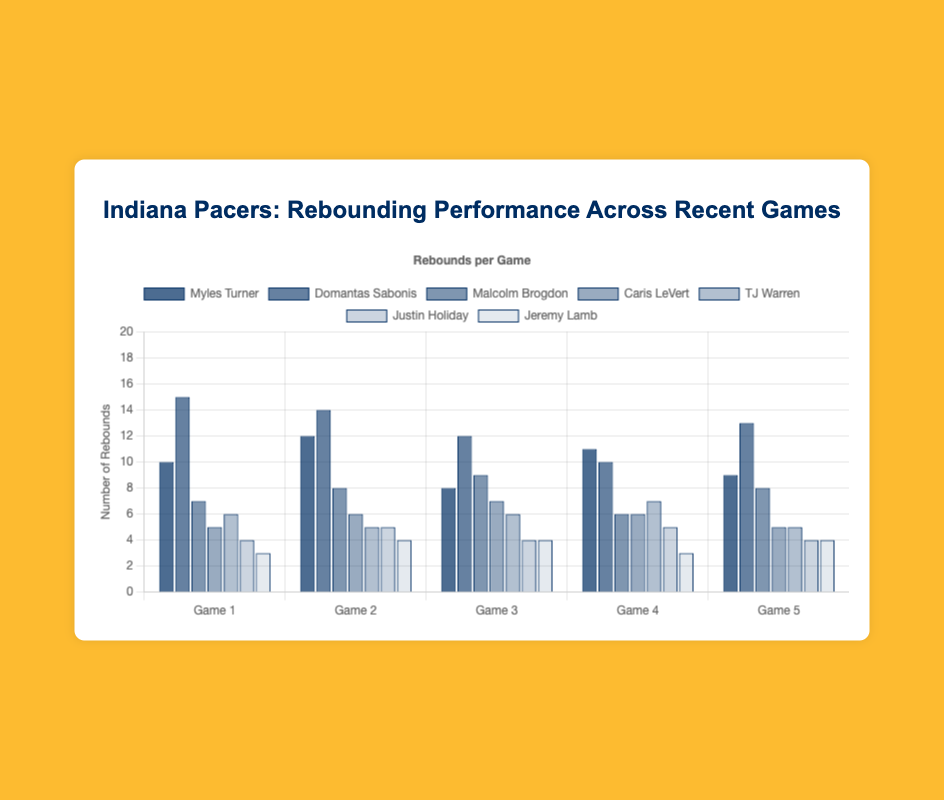Which player had the highest rebound count in Game 1? Check all the rebound counts for Game 1 - Myles Turner: 10, Domantas Sabonis: 15, Malcolm Brogdon: 7, Caris LeVert: 5, TJ Warren: 6, Justin Holiday: 4, Jeremy Lamb: 3. Domantas Sabonis has the highest rebound count with 15.
Answer: Domantas Sabonis What is the difference in total rebounds between the player with the most and the player with the least in Game 3? Calculate the total rebounds for each player in Game 3. The player with the most rebounds is Domantas Sabonis (12) and the player with the least is Justin Holiday (4). The difference is 12 - 4.
Answer: 8 Who showed the most consistent rebounding performance across all games? Consistency can be observed by minimal variation in rebounding numbers. Justin Holiday has a stable performance with 4, 5, 4, 5, 4. Check other players' variances to confirm.
Answer: Justin Holiday Which game did Myles Turner achieve his highest rebound count? Review the rebound counts for Myles Turner across all games: Game 1: 10, Game 2: 12, Game 3: 8, Game 4: 11, Game 5: 9. Highest value is 12 in Game 2.
Answer: Game 2 On average, how many rebounds per game did TJ Warren have? Calculate the average for TJ Warren by summing all his rebound counts (6+5+6+7+5) and divide by the number of games (5). The sum is 29, so the average is 29/5.
Answer: 5.8 In Game 5, which player had the second-highest rebound count? Review the rebound counts for Game 5 - Myles Turner: 9, Domantas Sabonis: 13, Malcolm Brogdon: 8, Caris LeVert: 5, TJ Warren: 5, Justin Holiday: 4, Jeremy Lamb: 4. Domantas Sabonis is highest with 13, and the second highest is Myles Turner with 9.
Answer: Myles Turner What was the total number of rebounds by Caris LeVert across all games? Sum the rebound counts for Caris LeVert for all the games: 5+6+7+6+5 = 29.
Answer: 29 Which game's rebounding performance had the least variation among all players? Check the span between the highest and lowest rebound count for each game. For example: Game 1 spans from 15(Sabonis) to 3(Lamb), Game 2 from 14(Sabonis) to 4(Lamb), and so forth. Calculate the difference for all games and find the least.
Answer: Game 4 Who scored fewer rebounds than TJ Warren in Game 3 but more in Game 4? Compare TJ Warren's rebounds (6, 7) with others in both games. Answer is in Game 3: Jeremy Lamb (4), and Game 4: Justin Holiday (5). Confirm it satisfies both conditions.
Answer: Justin Holiday Which player has the highest average rebound count across all games? Calculate the average rebound count for each player. Domantas Sabonis: (15+14+12+10+13)/5 = 12.8, Myles Turner averages less. Compute for all. Sabonis confirms highest.
Answer: Domantas Sabonis 